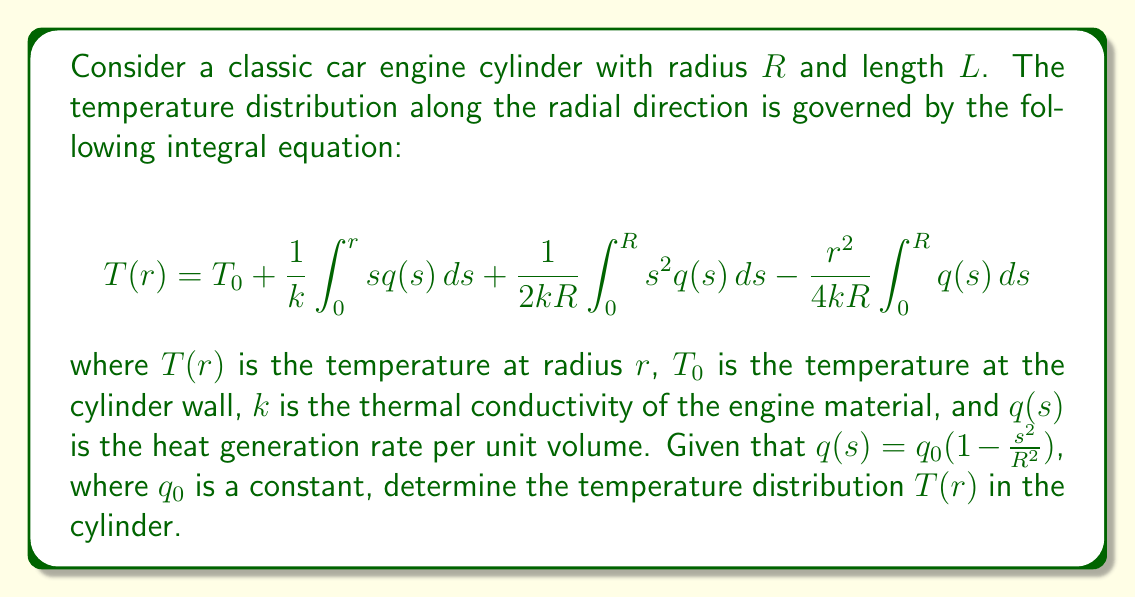Show me your answer to this math problem. To solve this integral equation, we need to evaluate the three integrals separately and then combine them:

1. First integral: $\int_0^r s q(s) ds$
   $$\int_0^r s q_0 (1 - \frac{s^2}{R^2}) ds = q_0 [\frac{s^2}{2} - \frac{s^4}{4R^2}]_0^r = q_0 (\frac{r^2}{2} - \frac{r^4}{4R^2})$$

2. Second integral: $\int_0^R s^2 q(s) ds$
   $$\int_0^R s^2 q_0 (1 - \frac{s^2}{R^2}) ds = q_0 [\frac{s^3}{3} - \frac{s^5}{5R^2}]_0^R = q_0 R^3 (\frac{1}{3} - \frac{1}{5}) = \frac{2q_0R^3}{15}$$

3. Third integral: $\int_0^R q(s) ds$
   $$\int_0^R q_0 (1 - \frac{s^2}{R^2}) ds = q_0 [s - \frac{s^3}{3R^2}]_0^R = q_0 R (\frac{2}{3})$$

Now, substituting these results back into the original equation:

$$T(r) = T_0 + \frac{q_0}{k} (\frac{r^2}{2} - \frac{r^4}{4R^2}) + \frac{q_0R^2}{30k} - \frac{q_0r^2}{6k}$$

Simplifying and rearranging:

$$T(r) = T_0 + \frac{q_0R^2}{k} [\frac{1}{30} + \frac{1}{3}(\frac{r^2}{R^2}) - \frac{1}{12}(\frac{r^4}{R^4})]$$

This is the final expression for the temperature distribution $T(r)$ in the cylinder.
Answer: $T(r) = T_0 + \frac{q_0R^2}{k} [\frac{1}{30} + \frac{1}{3}(\frac{r^2}{R^2}) - \frac{1}{12}(\frac{r^4}{R^4})]$ 